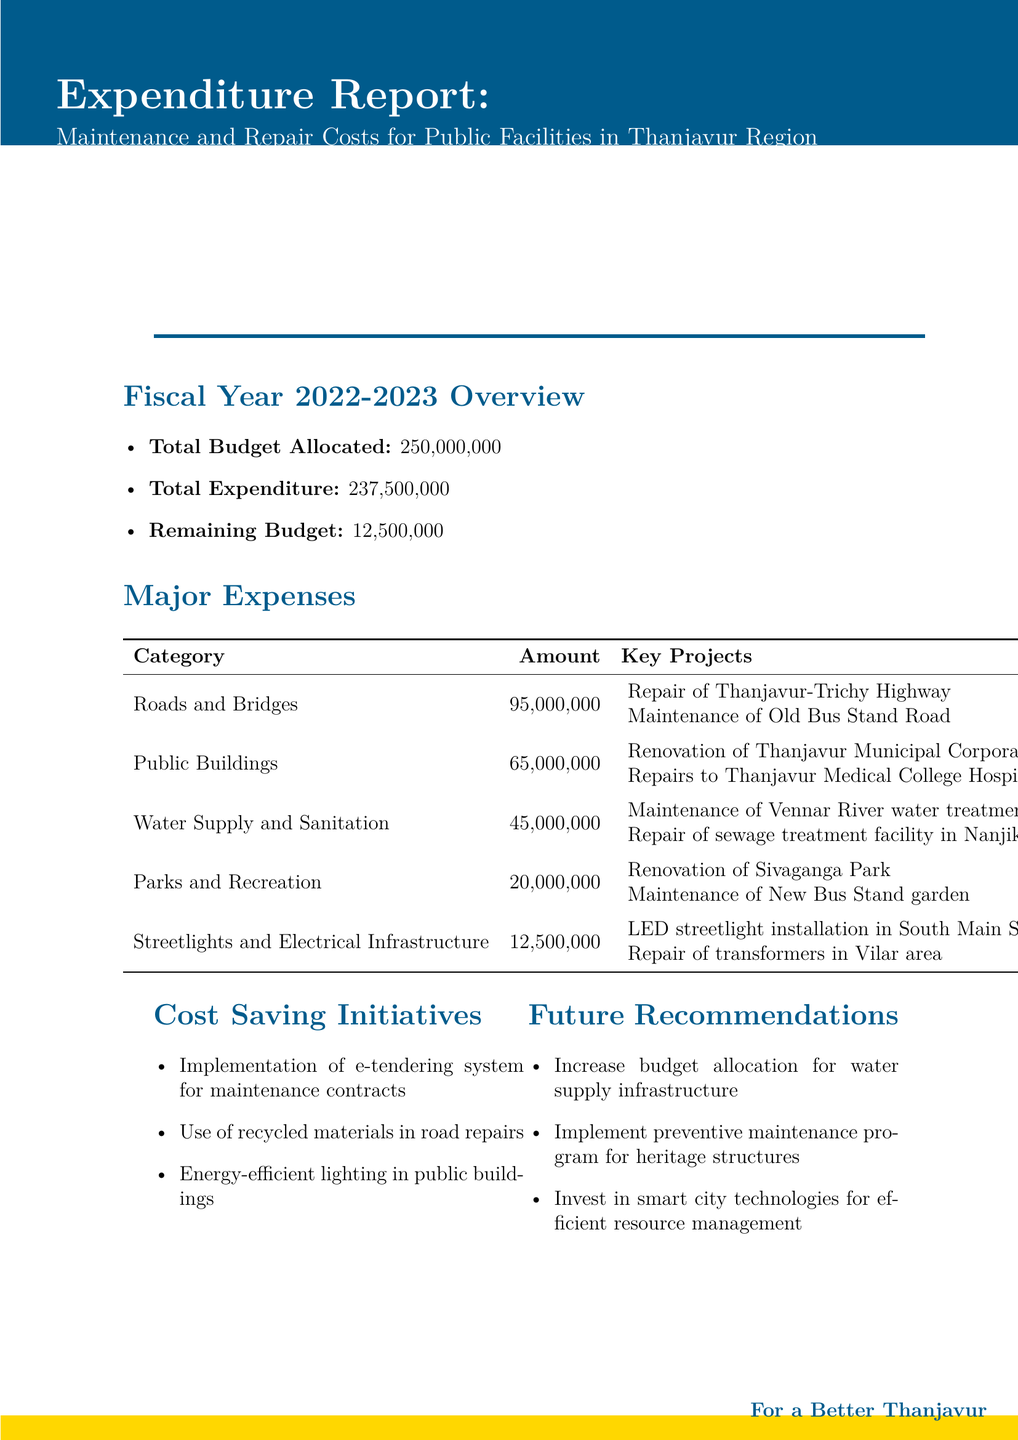What is the total budget allocated? The total budget allocated is clearly stated in the document as ₹250,000,000.
Answer: ₹250,000,000 How much was spent on Roads and Bridges? The amount spent on Roads and Bridges can be found in the major expenses section, which lists it as ₹95,000,000.
Answer: ₹95,000,000 What is the remaining budget at the end of the fiscal year? The remaining budget is specified in the overview section of the document as ₹12,500,000.
Answer: ₹12,500,000 Which project falls under Public Buildings? The key projects listed under Public Buildings include the Renovation of Thanjavur Municipal Corporation Office and Repairs to Thanjavur Medical College Hospital.
Answer: Renovation of Thanjavur Municipal Corporation Office What is a suggested future recommendation? The document suggests several future recommendations, such as increasing the budget allocation for water supply infrastructure.
Answer: Increase budget allocation for water supply infrastructure How much was spent on Water Supply and Sanitation? The amount allocated for Water Supply and Sanitation is detailed in the major expenses section, listed as ₹45,000,000.
Answer: ₹45,000,000 What initiative aims to save costs in maintenance contracts? One of the cost-saving initiatives mentioned is the implementation of an e-tendering system for maintenance contracts.
Answer: E-tendering system for maintenance contracts What is the total expenditure for the fiscal year? The total expenditure for the fiscal year is provided in the overview section and is stated as ₹237,500,000.
Answer: ₹237,500,000 How many categories of major expenses are listed? The document outlines five categories of major expenses related to public facilities.
Answer: Five 